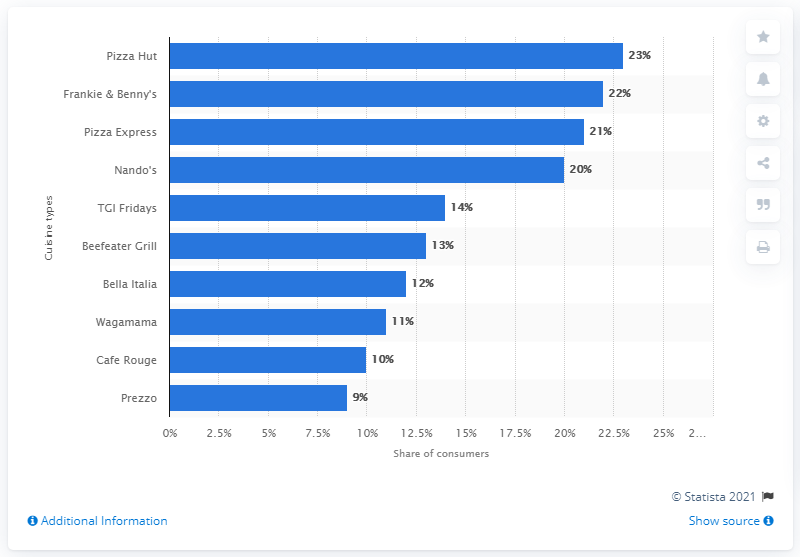Highlight a few significant elements in this photo. In 2016, Pizza Hut was the most visited restaurant chain in the UK. 